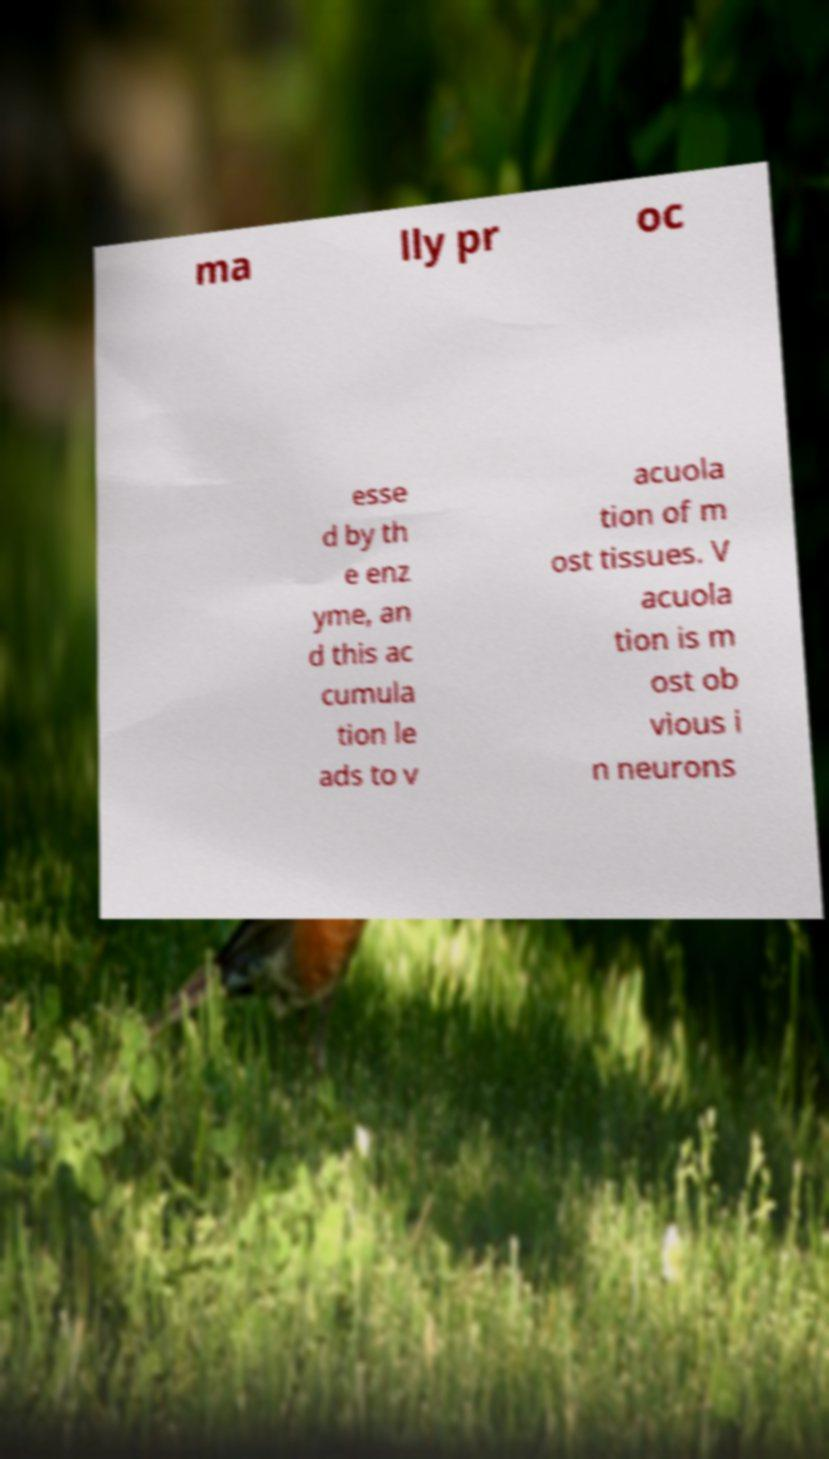Can you read and provide the text displayed in the image?This photo seems to have some interesting text. Can you extract and type it out for me? ma lly pr oc esse d by th e enz yme, an d this ac cumula tion le ads to v acuola tion of m ost tissues. V acuola tion is m ost ob vious i n neurons 